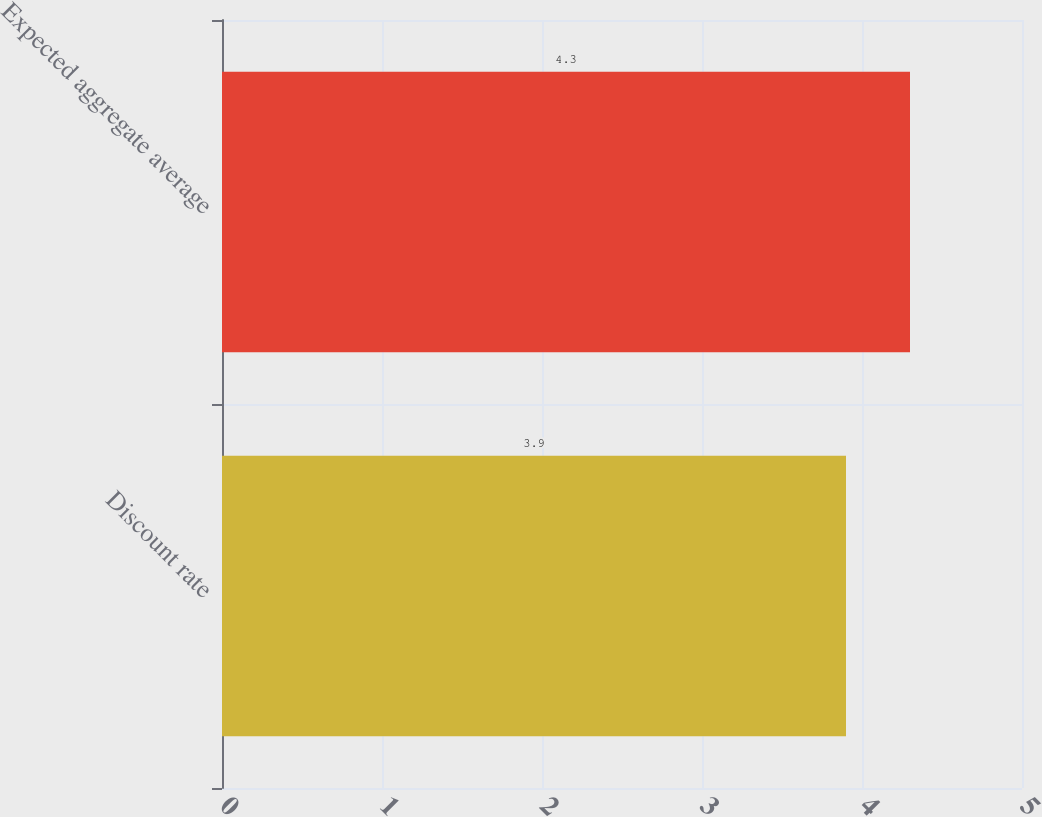Convert chart to OTSL. <chart><loc_0><loc_0><loc_500><loc_500><bar_chart><fcel>Discount rate<fcel>Expected aggregate average<nl><fcel>3.9<fcel>4.3<nl></chart> 